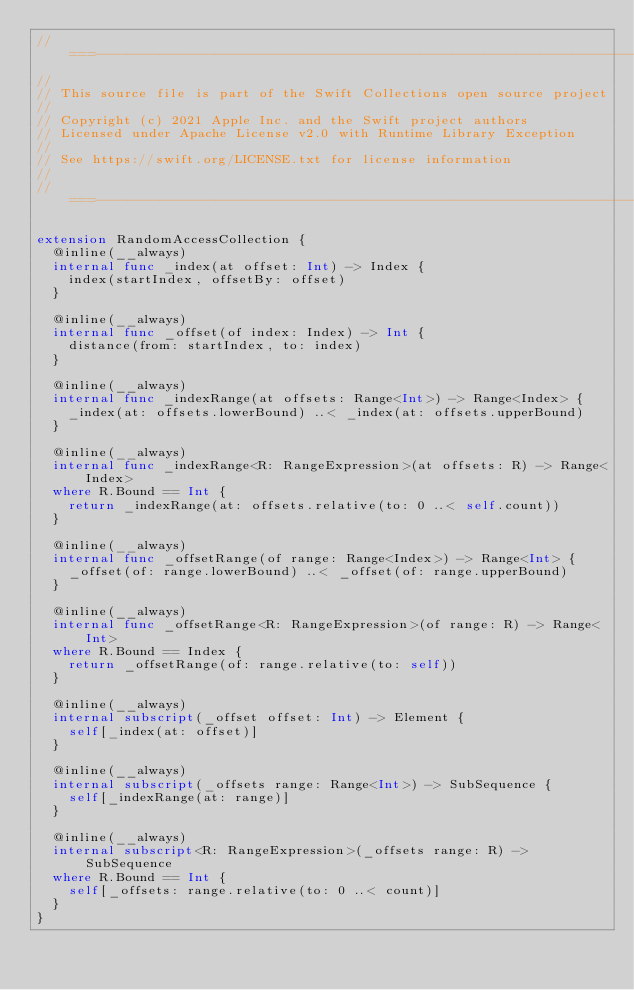<code> <loc_0><loc_0><loc_500><loc_500><_Swift_>//===----------------------------------------------------------------------===//
//
// This source file is part of the Swift Collections open source project
//
// Copyright (c) 2021 Apple Inc. and the Swift project authors
// Licensed under Apache License v2.0 with Runtime Library Exception
//
// See https://swift.org/LICENSE.txt for license information
//
//===----------------------------------------------------------------------===//

extension RandomAccessCollection {
  @inline(__always)
  internal func _index(at offset: Int) -> Index {
    index(startIndex, offsetBy: offset)
  }

  @inline(__always)
  internal func _offset(of index: Index) -> Int {
    distance(from: startIndex, to: index)
  }

  @inline(__always)
  internal func _indexRange(at offsets: Range<Int>) -> Range<Index> {
    _index(at: offsets.lowerBound) ..< _index(at: offsets.upperBound)
  }

  @inline(__always)
  internal func _indexRange<R: RangeExpression>(at offsets: R) -> Range<Index>
  where R.Bound == Int {
    return _indexRange(at: offsets.relative(to: 0 ..< self.count))
  }

  @inline(__always)
  internal func _offsetRange(of range: Range<Index>) -> Range<Int> {
    _offset(of: range.lowerBound) ..< _offset(of: range.upperBound)
  }

  @inline(__always)
  internal func _offsetRange<R: RangeExpression>(of range: R) -> Range<Int>
  where R.Bound == Index {
    return _offsetRange(of: range.relative(to: self))
  }

  @inline(__always)
  internal subscript(_offset offset: Int) -> Element {
    self[_index(at: offset)]
  }

  @inline(__always)
  internal subscript(_offsets range: Range<Int>) -> SubSequence {
    self[_indexRange(at: range)]
  }

  @inline(__always)
  internal subscript<R: RangeExpression>(_offsets range: R) -> SubSequence
  where R.Bound == Int {
    self[_offsets: range.relative(to: 0 ..< count)]
  }
}

</code> 